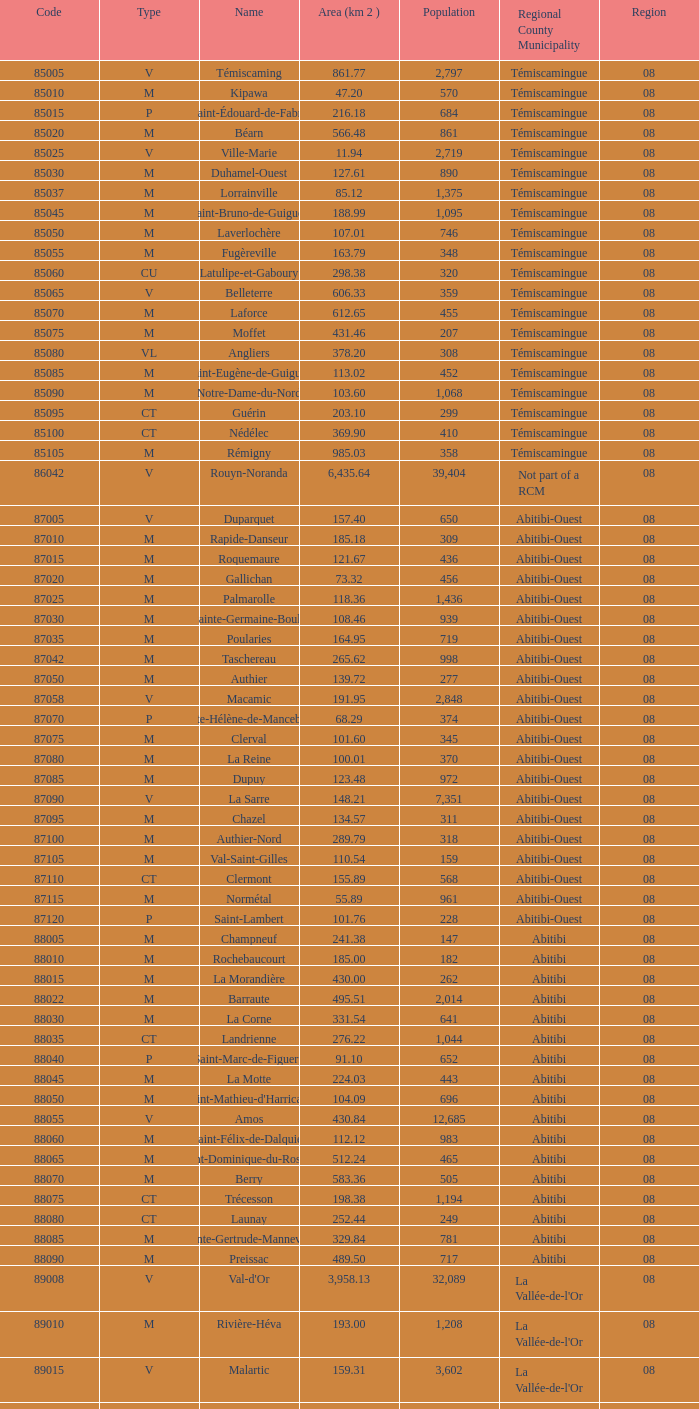31 km2? 0.0. 